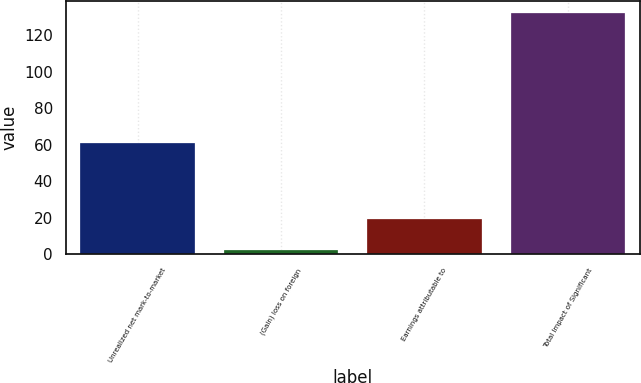Convert chart. <chart><loc_0><loc_0><loc_500><loc_500><bar_chart><fcel>Unrealized net mark-to-market<fcel>(Gain) loss on foreign<fcel>Earnings attributable to<fcel>Total Impact of Significant<nl><fcel>61<fcel>2<fcel>19<fcel>132<nl></chart> 